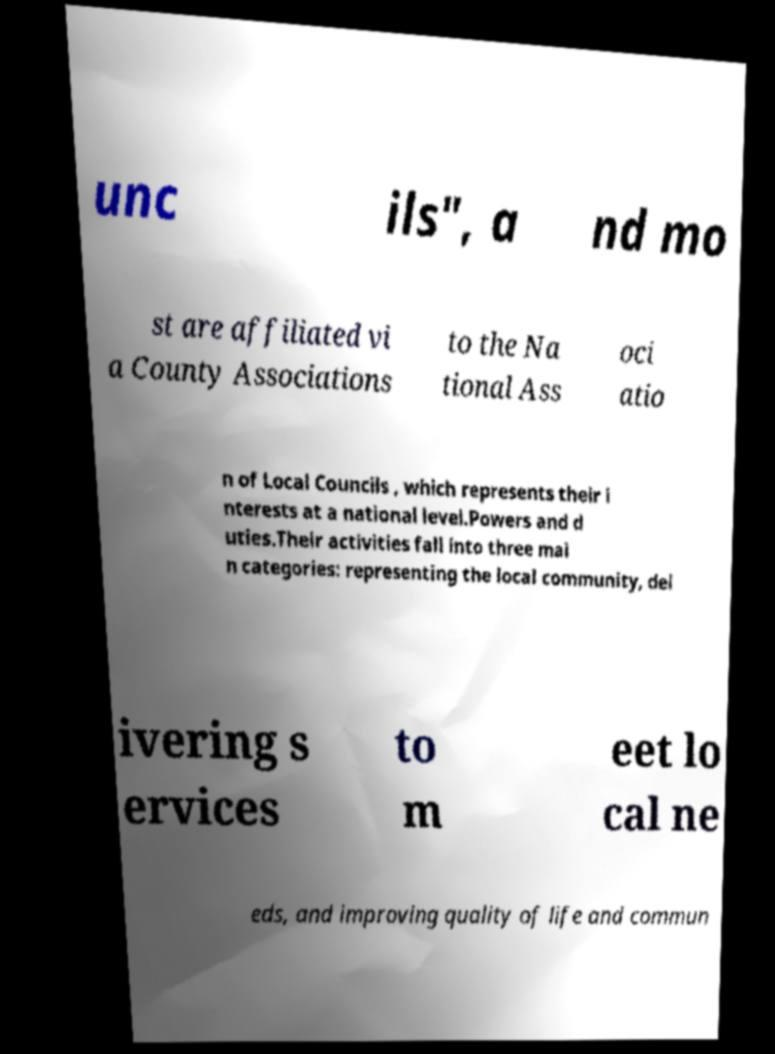What messages or text are displayed in this image? I need them in a readable, typed format. unc ils", a nd mo st are affiliated vi a County Associations to the Na tional Ass oci atio n of Local Councils , which represents their i nterests at a national level.Powers and d uties.Their activities fall into three mai n categories: representing the local community, del ivering s ervices to m eet lo cal ne eds, and improving quality of life and commun 